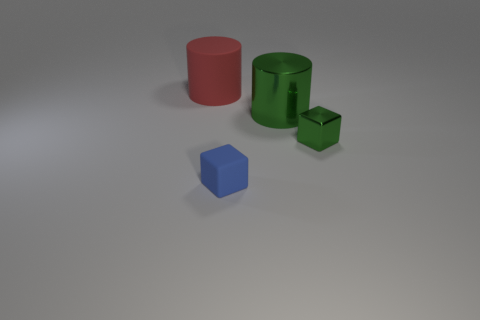Is the color of the metal cylinder the same as the tiny metallic cube?
Make the answer very short. Yes. There is a big cylinder that is the same color as the small shiny block; what is it made of?
Keep it short and to the point. Metal. What is the size of the metal thing that is the same shape as the red matte object?
Provide a succinct answer. Large. What number of other objects are the same color as the shiny cylinder?
Offer a terse response. 1. What number of balls are tiny blue things or rubber things?
Offer a terse response. 0. What color is the large object that is on the right side of the thing that is on the left side of the small rubber object?
Your response must be concise. Green. There is a big green metal object; what shape is it?
Offer a terse response. Cylinder. There is a cylinder that is in front of the rubber cylinder; does it have the same size as the tiny shiny cube?
Your response must be concise. No. Are there any tiny green things that have the same material as the large green thing?
Provide a short and direct response. Yes. What number of objects are small blocks that are to the right of the tiny matte block or large cyan shiny spheres?
Offer a very short reply. 1. 